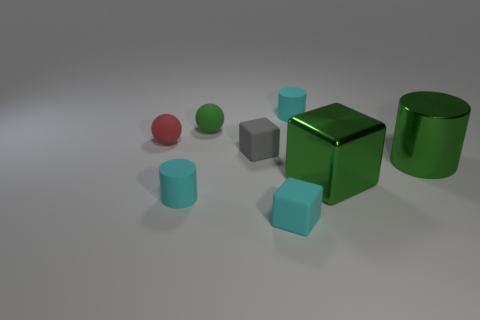There is a tiny matte sphere behind the red ball; is it the same color as the big metallic cylinder?
Your answer should be compact. Yes. There is a ball that is behind the red ball; are there any green blocks that are behind it?
Provide a short and direct response. No. Is the number of cylinders behind the big green metallic block less than the number of green objects to the right of the small red thing?
Your answer should be compact. Yes. There is a cube to the right of the small cyan thing that is in front of the cyan cylinder left of the gray matte block; what is its size?
Your response must be concise. Large. Do the red rubber ball left of the green ball and the small gray matte thing have the same size?
Keep it short and to the point. Yes. How many other things are made of the same material as the tiny gray block?
Give a very brief answer. 5. Is the number of small cyan objects greater than the number of cyan cylinders?
Offer a terse response. Yes. What material is the green cylinder that is behind the tiny cyan matte cylinder that is on the left side of the cyan thing that is behind the small green rubber thing?
Your answer should be compact. Metal. Is the color of the large metallic cylinder the same as the big block?
Give a very brief answer. Yes. Are there any big metal cubes that have the same color as the metal cylinder?
Give a very brief answer. Yes. 